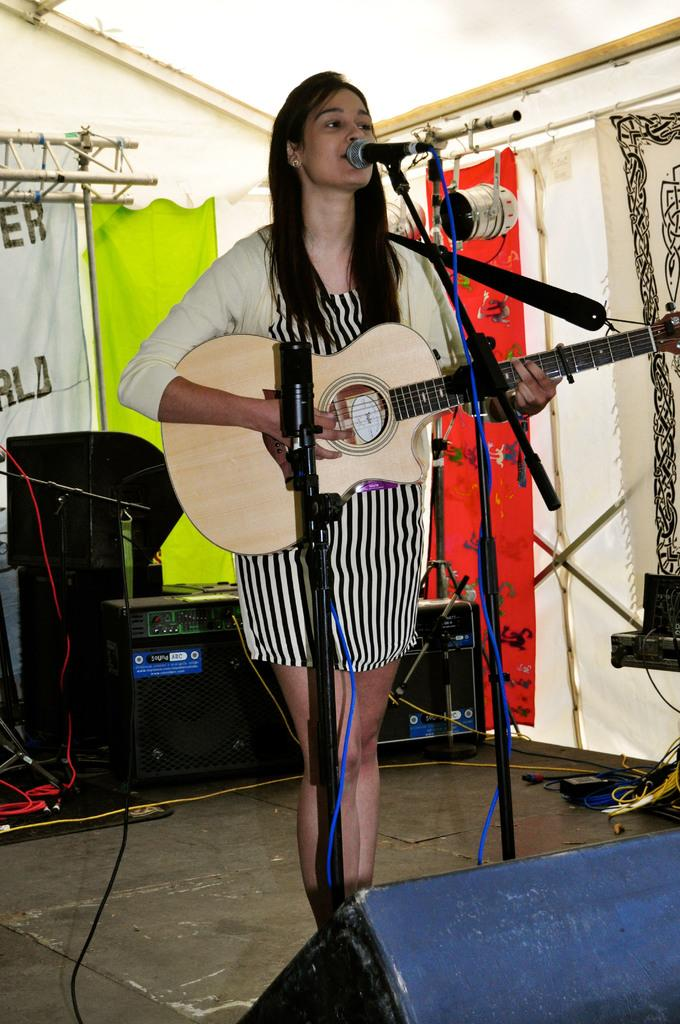What is the main subject of the image? The main subject of the image is a woman. What is the woman doing in the image? The woman is standing, singing, and playing the guitar. Can you describe the background of the image? There are objects in the background of the image. Is there any specific feature in the image related to the setting? Yes, there is a curtain in the image. What type of whip is the maid using to discipline the woman on the throne in the image? There is no maid, throne, or whip present in the image. The image features a woman standing, singing, and playing the guitar, with a curtain in the background. 